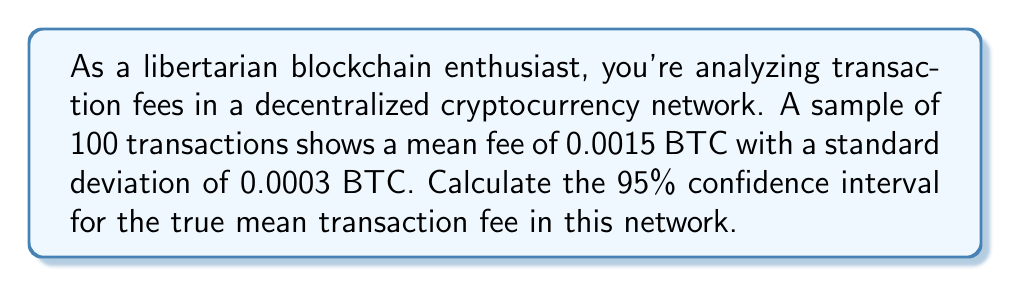Provide a solution to this math problem. Let's approach this step-by-step:

1) We're dealing with a confidence interval for a population mean with unknown population standard deviation. We'll use the t-distribution.

2) Given information:
   - Sample size: $n = 100$
   - Sample mean: $\bar{x} = 0.0015$ BTC
   - Sample standard deviation: $s = 0.0003$ BTC
   - Confidence level: 95%

3) The formula for the confidence interval is:

   $$\bar{x} \pm t_{\alpha/2, n-1} \cdot \frac{s}{\sqrt{n}}$$

4) For a 95% confidence interval, $\alpha = 0.05$, and $\alpha/2 = 0.025$

5) Degrees of freedom: $df = n - 1 = 99$

6) From the t-distribution table, $t_{0.025, 99} \approx 1.984$

7) Calculate the margin of error:

   $$1.984 \cdot \frac{0.0003}{\sqrt{100}} = 1.984 \cdot 0.00003 = 0.00005952$$

8) Calculate the confidence interval:

   Lower bound: $0.0015 - 0.00005952 = 0.00144048$
   Upper bound: $0.0015 + 0.00005952 = 0.00155952$

Therefore, we are 95% confident that the true mean transaction fee in this network is between 0.00144048 and 0.00155952 BTC.
Answer: (0.00144048, 0.00155952) BTC 